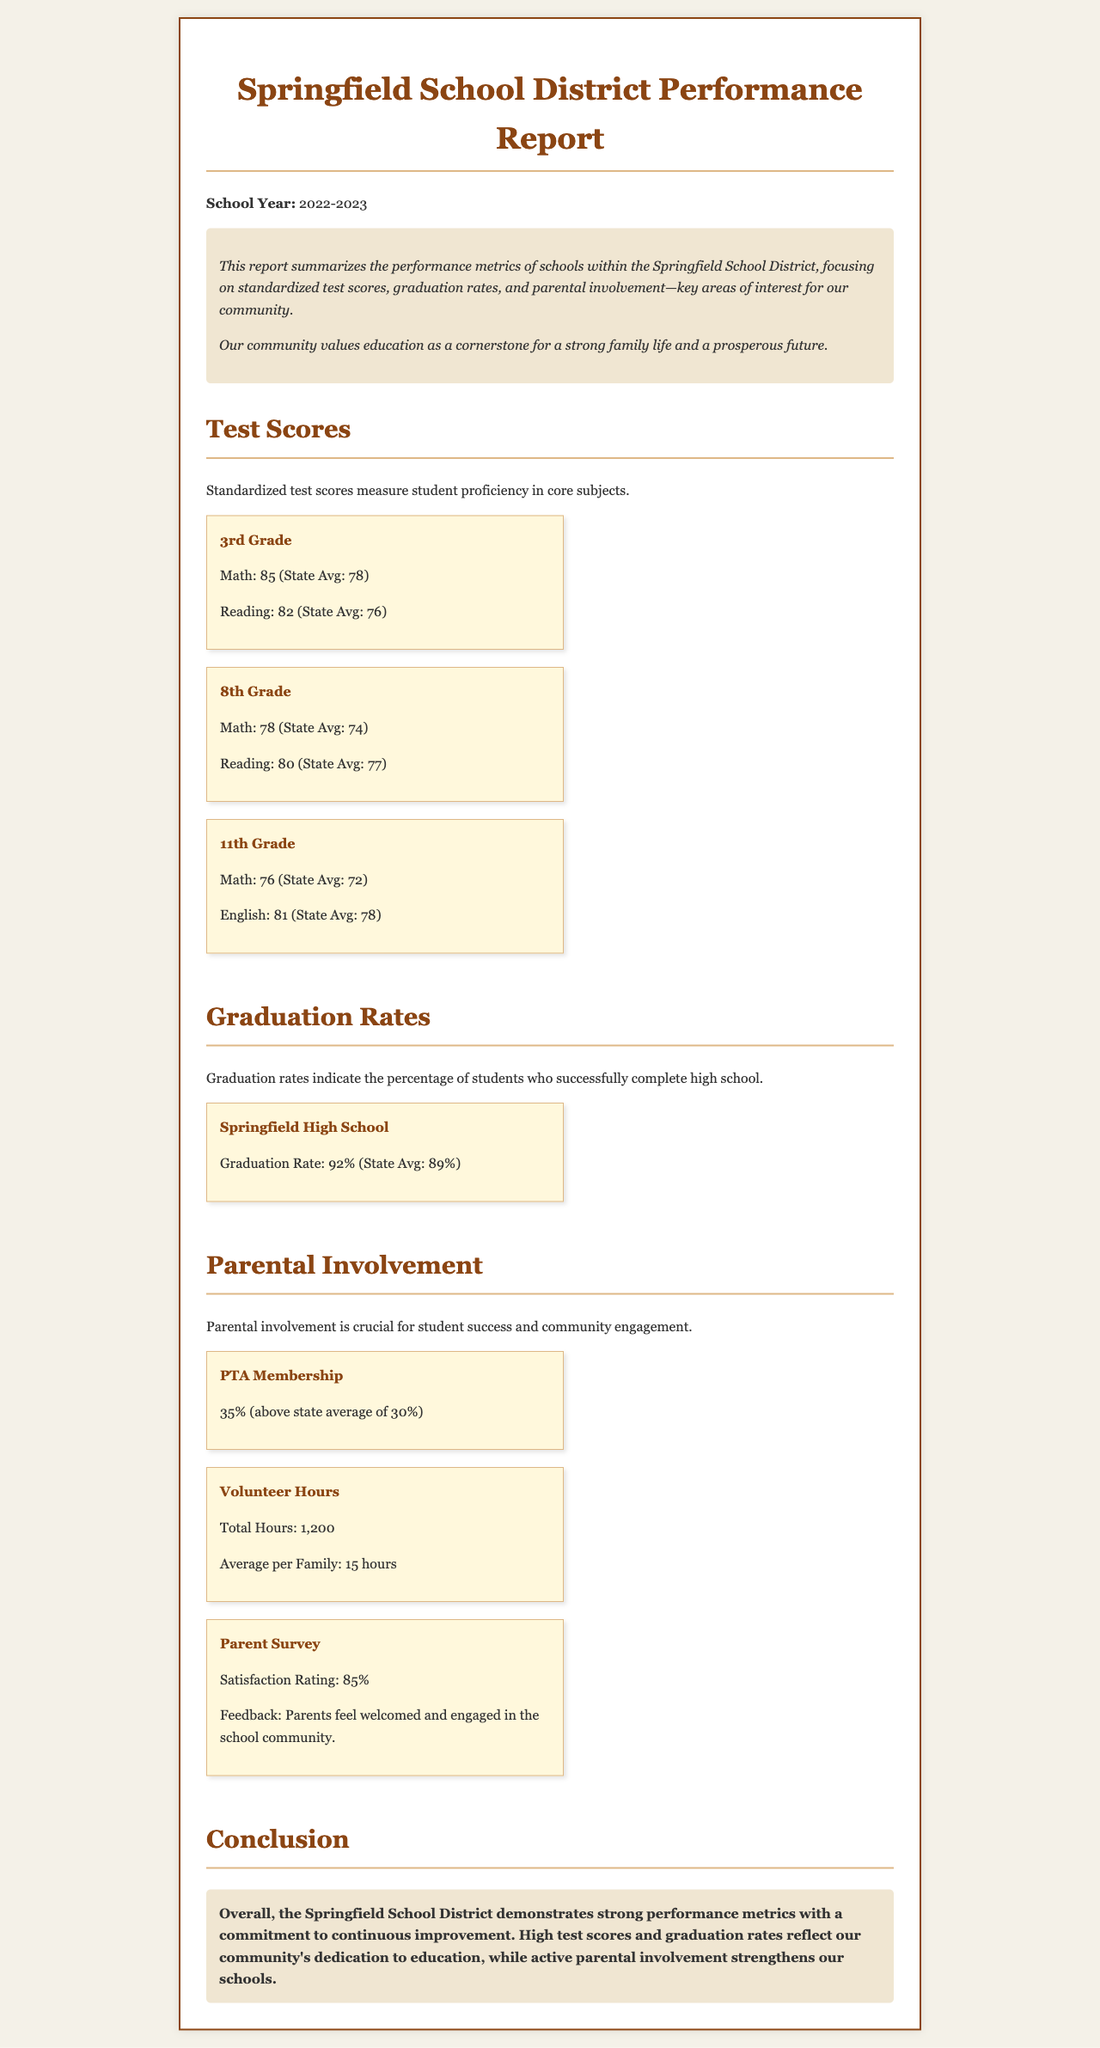what was the school year for the report? The report states the school year as 2022-2023.
Answer: 2022-2023 what is the 3rd grade math score? The document specifies the 3rd grade math score as 85, which is above the state average.
Answer: 85 what is the graduation rate for Springfield High School? The graduation rate mentioned for Springfield High School is 92%, which exceeds the state average.
Answer: 92% how many total volunteer hours were logged? The report indicates the total volunteer hours logged as 1,200 hours.
Answer: 1,200 what percentage of parents are members of the PTA? The document cites that 35% of parents are members of the PTA, which is above the state average.
Answer: 35% how does the 8th grade reading score compare to the state average? The 8th grade reading score is 80, while the state average is 77, indicating higher performance.
Answer: Higher what feedback did parents give regarding their involvement in the school? Parents feel welcomed and engaged in the school community, according to the parent survey feedback.
Answer: Welcomed and engaged what section of the report details standardized test scores? The section detailing standardized test scores is titled "Test Scores."
Answer: Test Scores what is the satisfaction rating given by parents in the survey? The satisfaction rating reported by parents is 85%.
Answer: 85% 